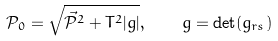<formula> <loc_0><loc_0><loc_500><loc_500>\mathcal { P } _ { 0 } = \sqrt { \vec { \mathcal { P } } ^ { 2 } + T ^ { 2 } | g | } , \quad g = \det ( g _ { r s } )</formula> 